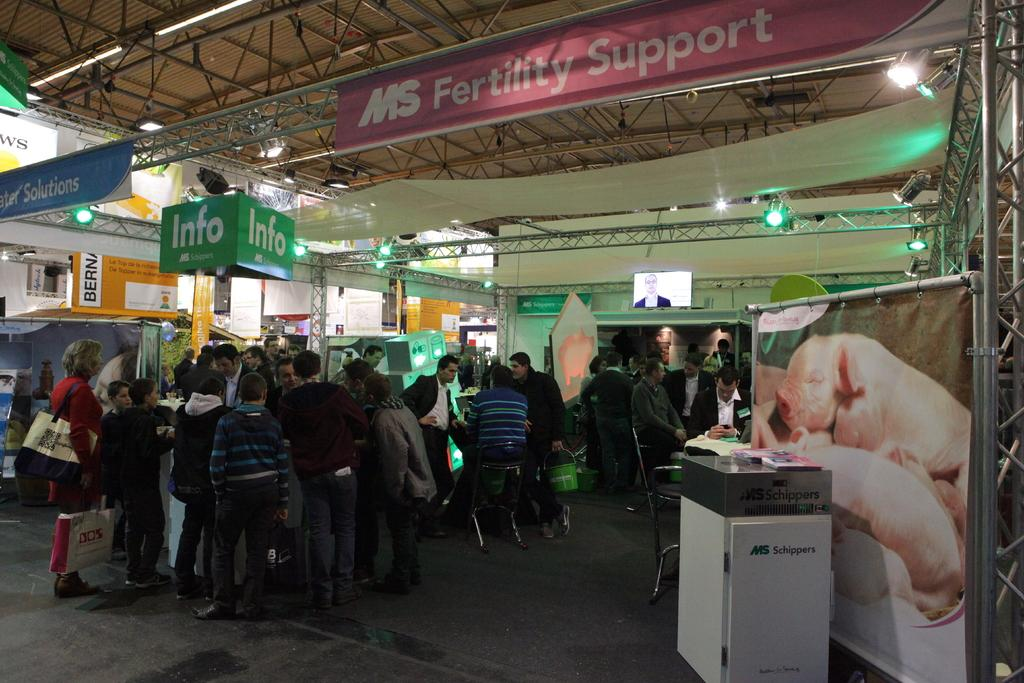<image>
Offer a succinct explanation of the picture presented. An area in a building labeled MS Fertility Support 